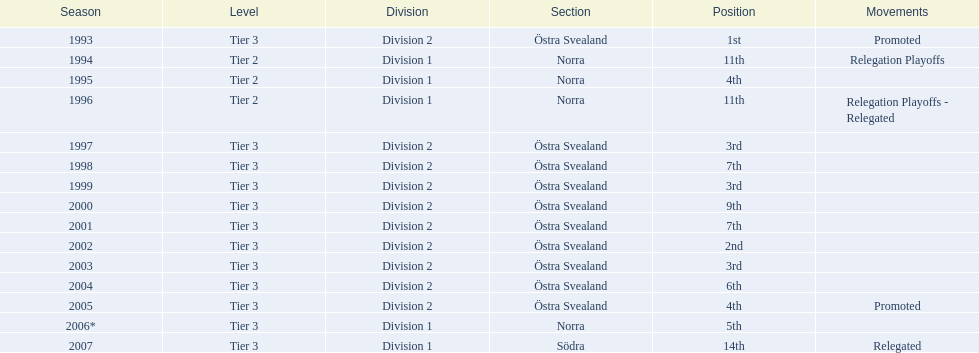In 2001, did their performance in the division improve or decline compared to their 9th place finish in 2000? Better. 